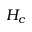Convert formula to latex. <formula><loc_0><loc_0><loc_500><loc_500>H _ { c }</formula> 